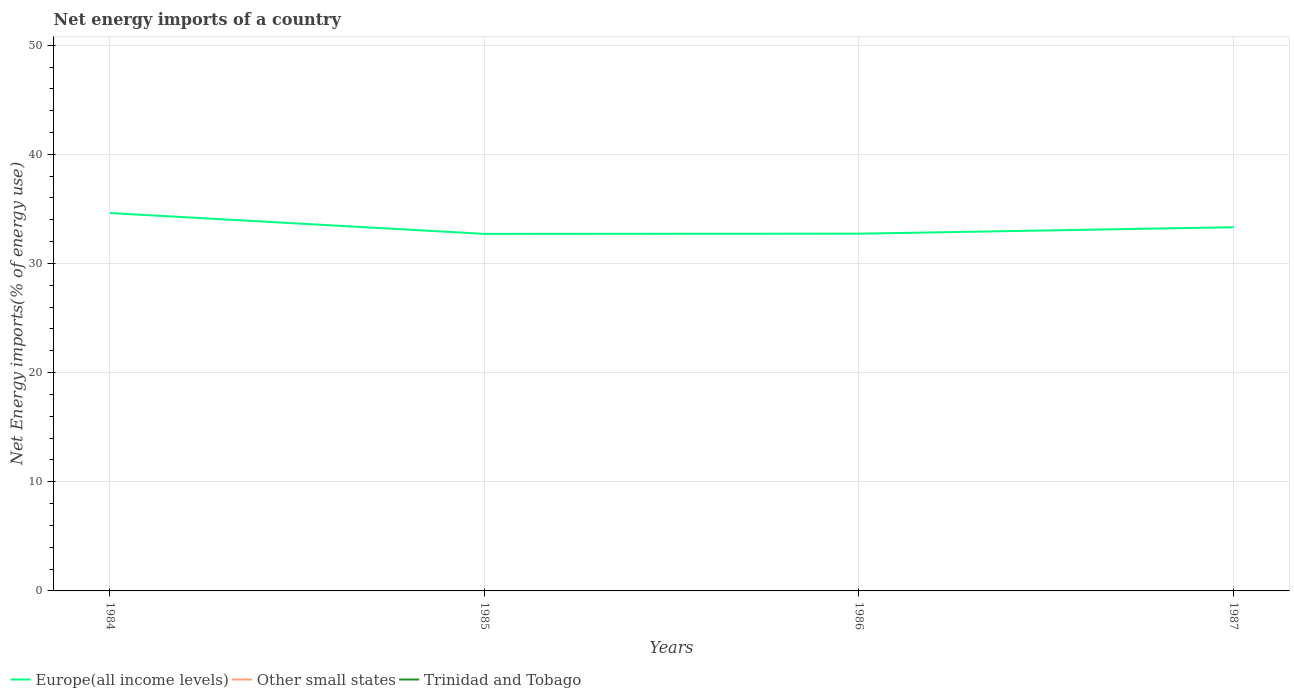Does the line corresponding to Europe(all income levels) intersect with the line corresponding to Other small states?
Your response must be concise. No. Across all years, what is the maximum net energy imports in Trinidad and Tobago?
Offer a terse response. 0. What is the total net energy imports in Europe(all income levels) in the graph?
Your answer should be compact. -0.02. What is the difference between the highest and the second highest net energy imports in Europe(all income levels)?
Ensure brevity in your answer.  1.91. Is the net energy imports in Trinidad and Tobago strictly greater than the net energy imports in Other small states over the years?
Give a very brief answer. No. What is the difference between two consecutive major ticks on the Y-axis?
Give a very brief answer. 10. Are the values on the major ticks of Y-axis written in scientific E-notation?
Provide a short and direct response. No. Does the graph contain any zero values?
Give a very brief answer. Yes. How many legend labels are there?
Provide a short and direct response. 3. What is the title of the graph?
Make the answer very short. Net energy imports of a country. Does "Nicaragua" appear as one of the legend labels in the graph?
Provide a succinct answer. No. What is the label or title of the X-axis?
Give a very brief answer. Years. What is the label or title of the Y-axis?
Your response must be concise. Net Energy imports(% of energy use). What is the Net Energy imports(% of energy use) in Europe(all income levels) in 1984?
Provide a short and direct response. 34.62. What is the Net Energy imports(% of energy use) of Other small states in 1984?
Keep it short and to the point. 0. What is the Net Energy imports(% of energy use) in Europe(all income levels) in 1985?
Provide a short and direct response. 32.71. What is the Net Energy imports(% of energy use) of Trinidad and Tobago in 1985?
Your response must be concise. 0. What is the Net Energy imports(% of energy use) of Europe(all income levels) in 1986?
Your answer should be compact. 32.73. What is the Net Energy imports(% of energy use) of Europe(all income levels) in 1987?
Give a very brief answer. 33.32. What is the Net Energy imports(% of energy use) in Other small states in 1987?
Offer a terse response. 0. What is the Net Energy imports(% of energy use) of Trinidad and Tobago in 1987?
Your answer should be very brief. 0. Across all years, what is the maximum Net Energy imports(% of energy use) of Europe(all income levels)?
Your answer should be compact. 34.62. Across all years, what is the minimum Net Energy imports(% of energy use) of Europe(all income levels)?
Make the answer very short. 32.71. What is the total Net Energy imports(% of energy use) in Europe(all income levels) in the graph?
Provide a succinct answer. 133.39. What is the total Net Energy imports(% of energy use) of Trinidad and Tobago in the graph?
Ensure brevity in your answer.  0. What is the difference between the Net Energy imports(% of energy use) in Europe(all income levels) in 1984 and that in 1985?
Your answer should be very brief. 1.91. What is the difference between the Net Energy imports(% of energy use) of Europe(all income levels) in 1984 and that in 1986?
Make the answer very short. 1.89. What is the difference between the Net Energy imports(% of energy use) of Europe(all income levels) in 1984 and that in 1987?
Give a very brief answer. 1.3. What is the difference between the Net Energy imports(% of energy use) of Europe(all income levels) in 1985 and that in 1986?
Keep it short and to the point. -0.02. What is the difference between the Net Energy imports(% of energy use) in Europe(all income levels) in 1985 and that in 1987?
Provide a succinct answer. -0.61. What is the difference between the Net Energy imports(% of energy use) in Europe(all income levels) in 1986 and that in 1987?
Your answer should be compact. -0.59. What is the average Net Energy imports(% of energy use) in Europe(all income levels) per year?
Your answer should be compact. 33.35. What is the average Net Energy imports(% of energy use) of Other small states per year?
Make the answer very short. 0. What is the average Net Energy imports(% of energy use) in Trinidad and Tobago per year?
Offer a very short reply. 0. What is the ratio of the Net Energy imports(% of energy use) of Europe(all income levels) in 1984 to that in 1985?
Keep it short and to the point. 1.06. What is the ratio of the Net Energy imports(% of energy use) of Europe(all income levels) in 1984 to that in 1986?
Provide a short and direct response. 1.06. What is the ratio of the Net Energy imports(% of energy use) of Europe(all income levels) in 1984 to that in 1987?
Provide a short and direct response. 1.04. What is the ratio of the Net Energy imports(% of energy use) in Europe(all income levels) in 1985 to that in 1986?
Your answer should be compact. 1. What is the ratio of the Net Energy imports(% of energy use) of Europe(all income levels) in 1985 to that in 1987?
Offer a terse response. 0.98. What is the ratio of the Net Energy imports(% of energy use) in Europe(all income levels) in 1986 to that in 1987?
Give a very brief answer. 0.98. What is the difference between the highest and the second highest Net Energy imports(% of energy use) in Europe(all income levels)?
Provide a short and direct response. 1.3. What is the difference between the highest and the lowest Net Energy imports(% of energy use) of Europe(all income levels)?
Keep it short and to the point. 1.91. 